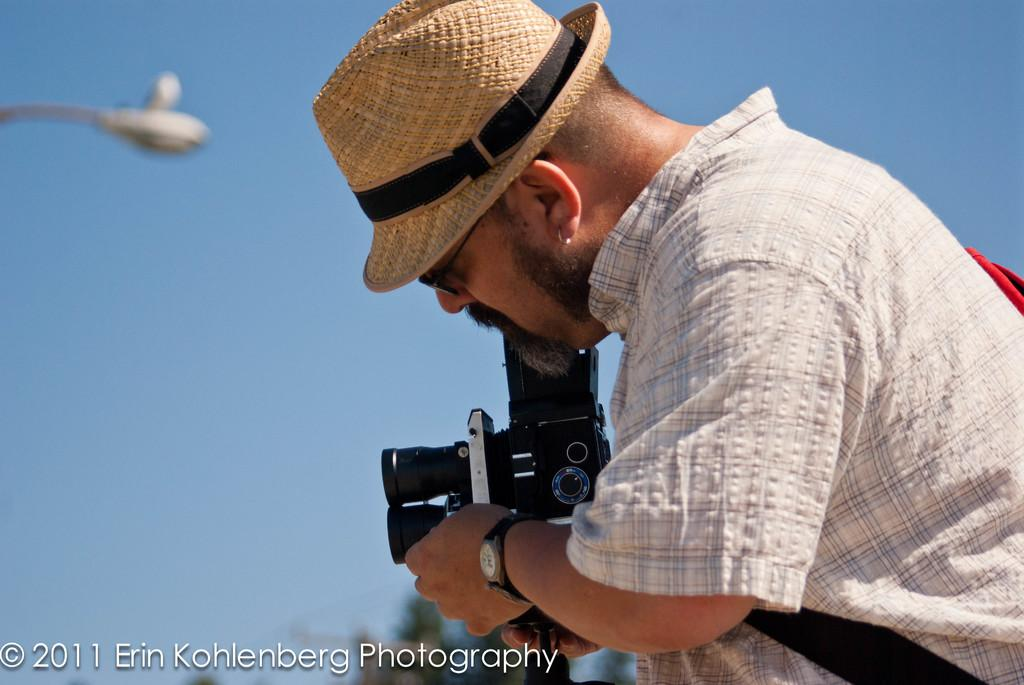Who is the main subject in the foreground of the image? There is a man in the foreground of the image. On which side of the image is the man located? The man is on the right side of the image. What is the man wearing in the image? The man is wearing a hat. What is the man holding in the image? The man is holding a camera. What can be seen in the background of the image? There is a sky and a street light visible in the background of the image. What type of turkey can be seen walking down the street in the image? There is no turkey present in the image; it features a man holding a camera. What rule is being enforced by the man in the image? There is no indication of any rule enforcement in the image; the man is simply holding a camera. 